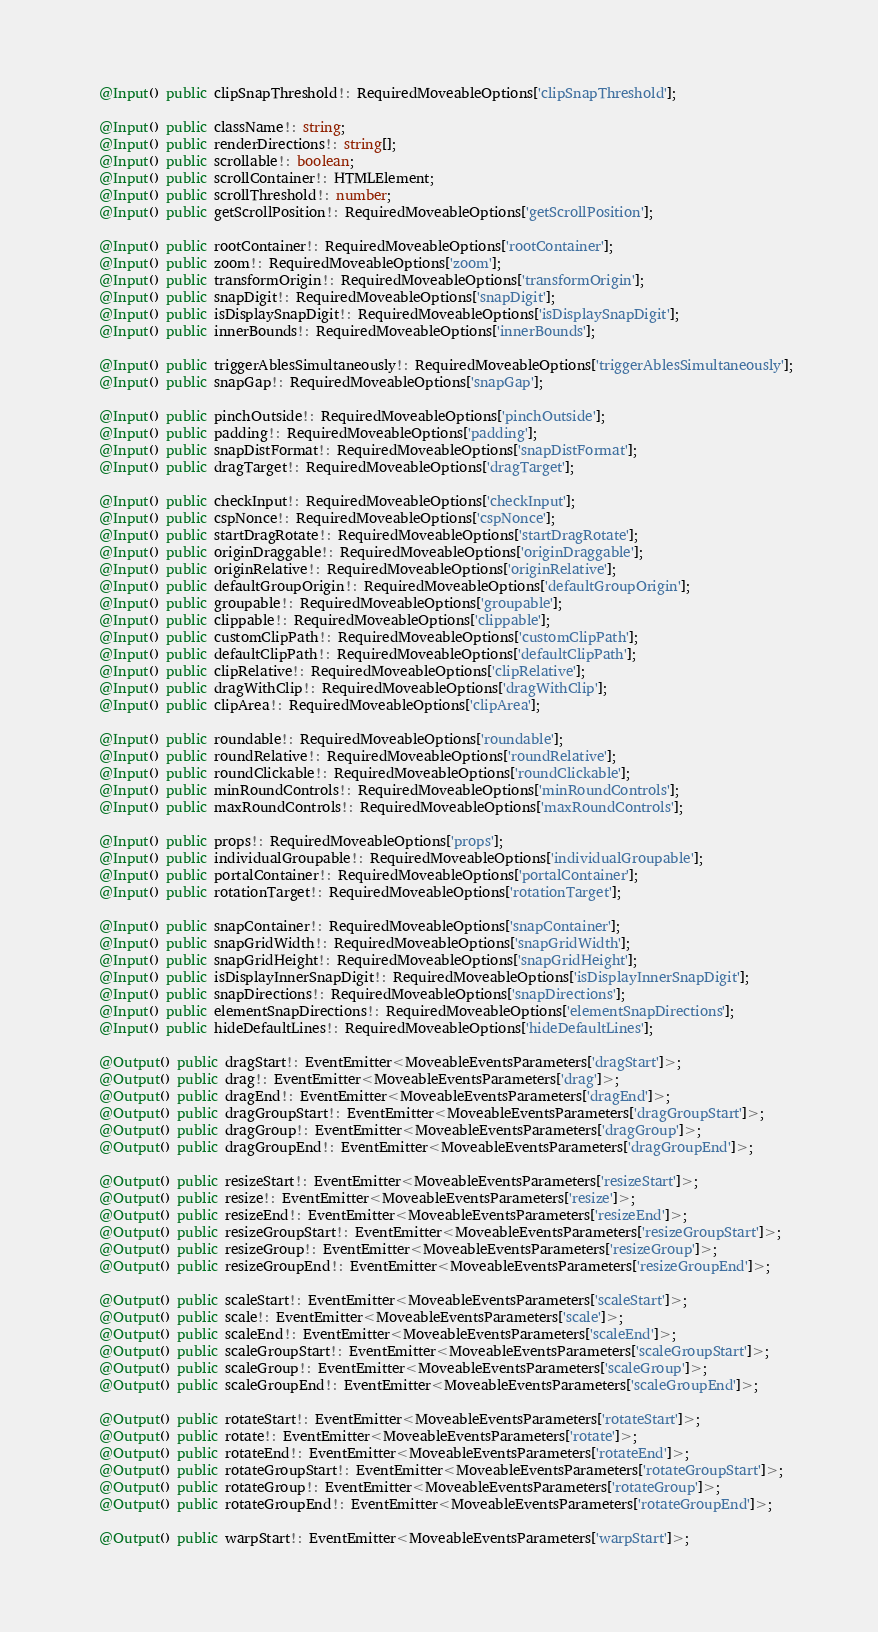<code> <loc_0><loc_0><loc_500><loc_500><_TypeScript_>  @Input() public clipSnapThreshold!: RequiredMoveableOptions['clipSnapThreshold'];

  @Input() public className!: string;
  @Input() public renderDirections!: string[];
  @Input() public scrollable!: boolean;
  @Input() public scrollContainer!: HTMLElement;
  @Input() public scrollThreshold!: number;
  @Input() public getScrollPosition!: RequiredMoveableOptions['getScrollPosition'];

  @Input() public rootContainer!: RequiredMoveableOptions['rootContainer'];
  @Input() public zoom!: RequiredMoveableOptions['zoom'];
  @Input() public transformOrigin!: RequiredMoveableOptions['transformOrigin'];
  @Input() public snapDigit!: RequiredMoveableOptions['snapDigit'];
  @Input() public isDisplaySnapDigit!: RequiredMoveableOptions['isDisplaySnapDigit'];
  @Input() public innerBounds!: RequiredMoveableOptions['innerBounds'];

  @Input() public triggerAblesSimultaneously!: RequiredMoveableOptions['triggerAblesSimultaneously'];
  @Input() public snapGap!: RequiredMoveableOptions['snapGap'];

  @Input() public pinchOutside!: RequiredMoveableOptions['pinchOutside'];
  @Input() public padding!: RequiredMoveableOptions['padding'];
  @Input() public snapDistFormat!: RequiredMoveableOptions['snapDistFormat'];
  @Input() public dragTarget!: RequiredMoveableOptions['dragTarget'];

  @Input() public checkInput!: RequiredMoveableOptions['checkInput'];
  @Input() public cspNonce!: RequiredMoveableOptions['cspNonce'];
  @Input() public startDragRotate!: RequiredMoveableOptions['startDragRotate'];
  @Input() public originDraggable!: RequiredMoveableOptions['originDraggable'];
  @Input() public originRelative!: RequiredMoveableOptions['originRelative'];
  @Input() public defaultGroupOrigin!: RequiredMoveableOptions['defaultGroupOrigin'];
  @Input() public groupable!: RequiredMoveableOptions['groupable'];
  @Input() public clippable!: RequiredMoveableOptions['clippable'];
  @Input() public customClipPath!: RequiredMoveableOptions['customClipPath'];
  @Input() public defaultClipPath!: RequiredMoveableOptions['defaultClipPath'];
  @Input() public clipRelative!: RequiredMoveableOptions['clipRelative'];
  @Input() public dragWithClip!: RequiredMoveableOptions['dragWithClip'];
  @Input() public clipArea!: RequiredMoveableOptions['clipArea'];

  @Input() public roundable!: RequiredMoveableOptions['roundable'];
  @Input() public roundRelative!: RequiredMoveableOptions['roundRelative'];
  @Input() public roundClickable!: RequiredMoveableOptions['roundClickable'];
  @Input() public minRoundControls!: RequiredMoveableOptions['minRoundControls'];
  @Input() public maxRoundControls!: RequiredMoveableOptions['maxRoundControls'];

  @Input() public props!: RequiredMoveableOptions['props'];
  @Input() public individualGroupable!: RequiredMoveableOptions['individualGroupable'];
  @Input() public portalContainer!: RequiredMoveableOptions['portalContainer'];
  @Input() public rotationTarget!: RequiredMoveableOptions['rotationTarget'];

  @Input() public snapContainer!: RequiredMoveableOptions['snapContainer'];
  @Input() public snapGridWidth!: RequiredMoveableOptions['snapGridWidth'];
  @Input() public snapGridHeight!: RequiredMoveableOptions['snapGridHeight'];
  @Input() public isDisplayInnerSnapDigit!: RequiredMoveableOptions['isDisplayInnerSnapDigit'];
  @Input() public snapDirections!: RequiredMoveableOptions['snapDirections'];
  @Input() public elementSnapDirections!: RequiredMoveableOptions['elementSnapDirections'];
  @Input() public hideDefaultLines!: RequiredMoveableOptions['hideDefaultLines'];

  @Output() public dragStart!: EventEmitter<MoveableEventsParameters['dragStart']>;
  @Output() public drag!: EventEmitter<MoveableEventsParameters['drag']>;
  @Output() public dragEnd!: EventEmitter<MoveableEventsParameters['dragEnd']>;
  @Output() public dragGroupStart!: EventEmitter<MoveableEventsParameters['dragGroupStart']>;
  @Output() public dragGroup!: EventEmitter<MoveableEventsParameters['dragGroup']>;
  @Output() public dragGroupEnd!: EventEmitter<MoveableEventsParameters['dragGroupEnd']>;

  @Output() public resizeStart!: EventEmitter<MoveableEventsParameters['resizeStart']>;
  @Output() public resize!: EventEmitter<MoveableEventsParameters['resize']>;
  @Output() public resizeEnd!: EventEmitter<MoveableEventsParameters['resizeEnd']>;
  @Output() public resizeGroupStart!: EventEmitter<MoveableEventsParameters['resizeGroupStart']>;
  @Output() public resizeGroup!: EventEmitter<MoveableEventsParameters['resizeGroup']>;
  @Output() public resizeGroupEnd!: EventEmitter<MoveableEventsParameters['resizeGroupEnd']>;

  @Output() public scaleStart!: EventEmitter<MoveableEventsParameters['scaleStart']>;
  @Output() public scale!: EventEmitter<MoveableEventsParameters['scale']>;
  @Output() public scaleEnd!: EventEmitter<MoveableEventsParameters['scaleEnd']>;
  @Output() public scaleGroupStart!: EventEmitter<MoveableEventsParameters['scaleGroupStart']>;
  @Output() public scaleGroup!: EventEmitter<MoveableEventsParameters['scaleGroup']>;
  @Output() public scaleGroupEnd!: EventEmitter<MoveableEventsParameters['scaleGroupEnd']>;

  @Output() public rotateStart!: EventEmitter<MoveableEventsParameters['rotateStart']>;
  @Output() public rotate!: EventEmitter<MoveableEventsParameters['rotate']>;
  @Output() public rotateEnd!: EventEmitter<MoveableEventsParameters['rotateEnd']>;
  @Output() public rotateGroupStart!: EventEmitter<MoveableEventsParameters['rotateGroupStart']>;
  @Output() public rotateGroup!: EventEmitter<MoveableEventsParameters['rotateGroup']>;
  @Output() public rotateGroupEnd!: EventEmitter<MoveableEventsParameters['rotateGroupEnd']>;

  @Output() public warpStart!: EventEmitter<MoveableEventsParameters['warpStart']>;</code> 